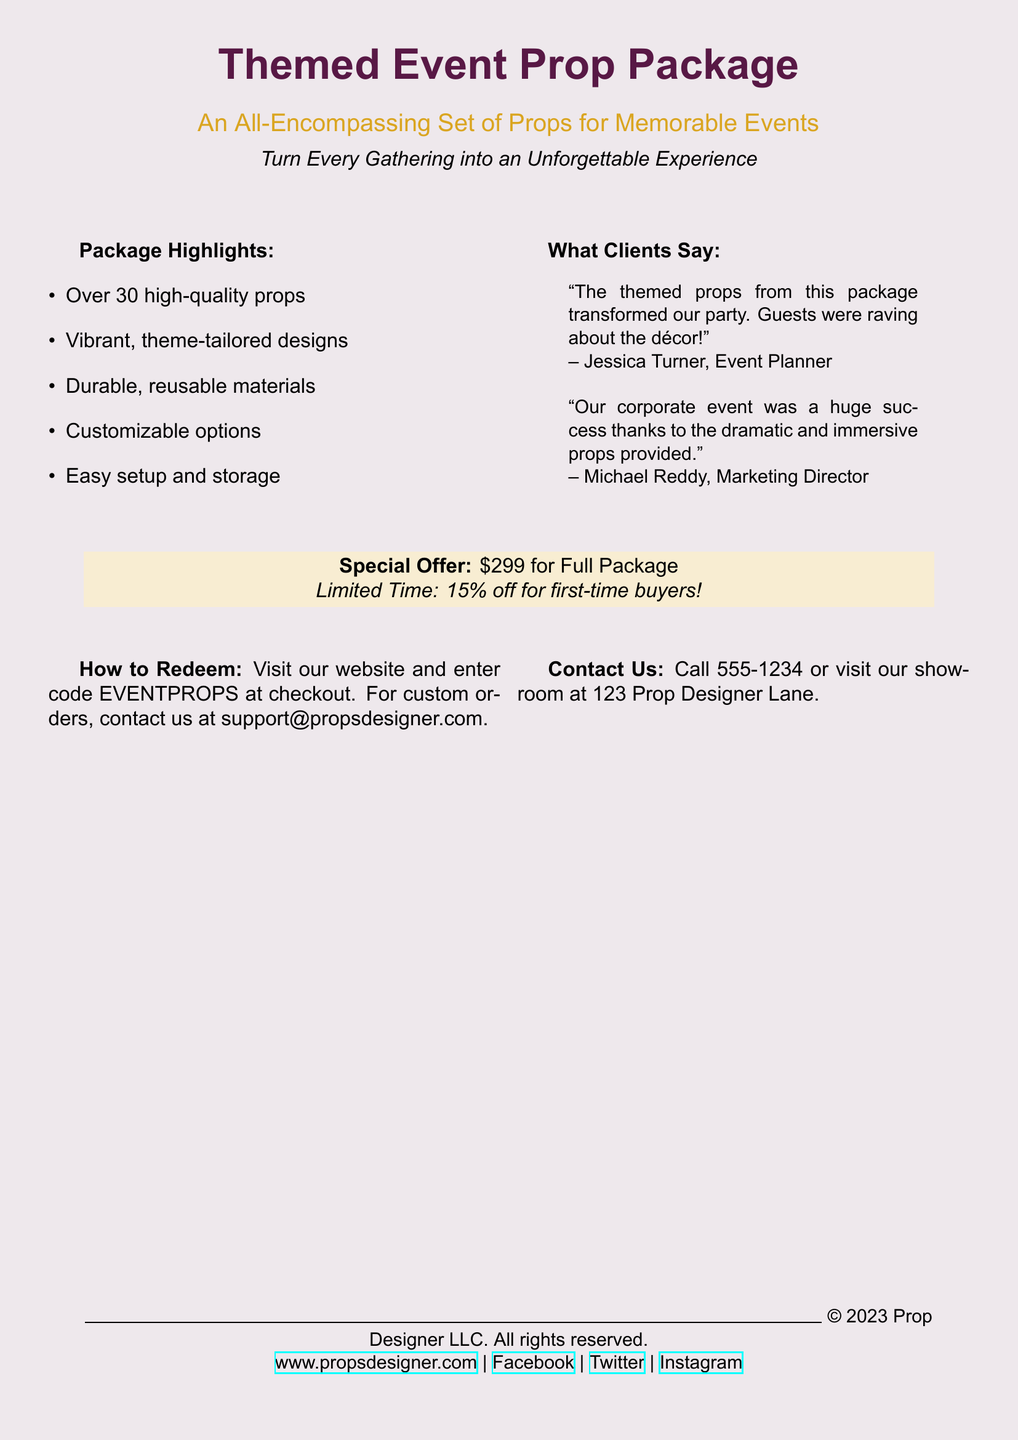What is the theme of the prop package? The theme of the prop package is captured in the title, which emphasizes themed events.
Answer: Themed Event Prop Package How many props are included in the package? The document lists that there are over 30 props included in the package.
Answer: Over 30 What is the special offer for first-time buyers? The special offer for first-time buyers is detailed in the special offer section of the document.
Answer: 15% off What is the price of the full package? The document specifies the price of the full package, which is prominently displayed.
Answer: $299 What materials are the props made from? The document states that the props are made from durable, reusable materials.
Answer: Durable, reusable materials How can clients redeem the offer? The process for redemption involves visiting the website and using a specific code mentioned in the document.
Answer: Enter code EVENTPROPS at checkout Who is quoted in the client testimonials? The document includes testimonials from specific individuals, providing their names and roles.
Answer: Jessica Turner and Michael Reddy What color is used as the background of the document? The document's background color is described in the beginning section, indicating its aesthetic choice.
Answer: Burgundy What is the email contact for custom orders? The document explicitly mentions an email address for inquiries about custom orders.
Answer: support@propsdesigner.com 